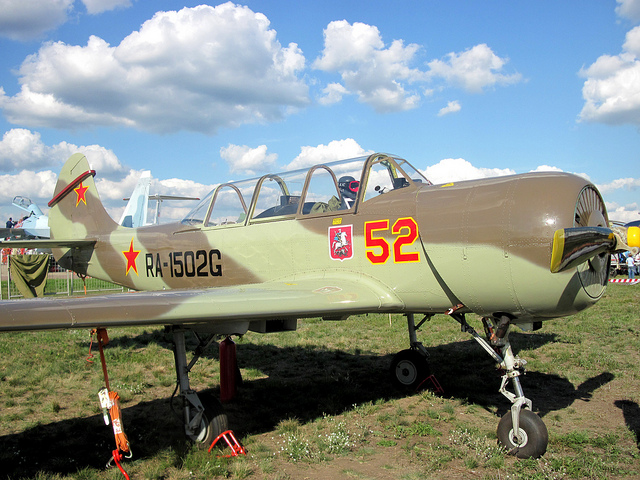Please transcribe the text information in this image. 52 RA -1502G 